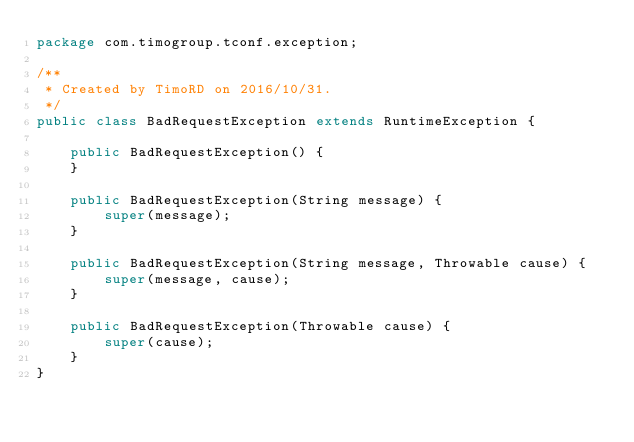<code> <loc_0><loc_0><loc_500><loc_500><_Java_>package com.timogroup.tconf.exception;

/**
 * Created by TimoRD on 2016/10/31.
 */
public class BadRequestException extends RuntimeException {

    public BadRequestException() {
    }

    public BadRequestException(String message) {
        super(message);
    }

    public BadRequestException(String message, Throwable cause) {
        super(message, cause);
    }

    public BadRequestException(Throwable cause) {
        super(cause);
    }
}
</code> 